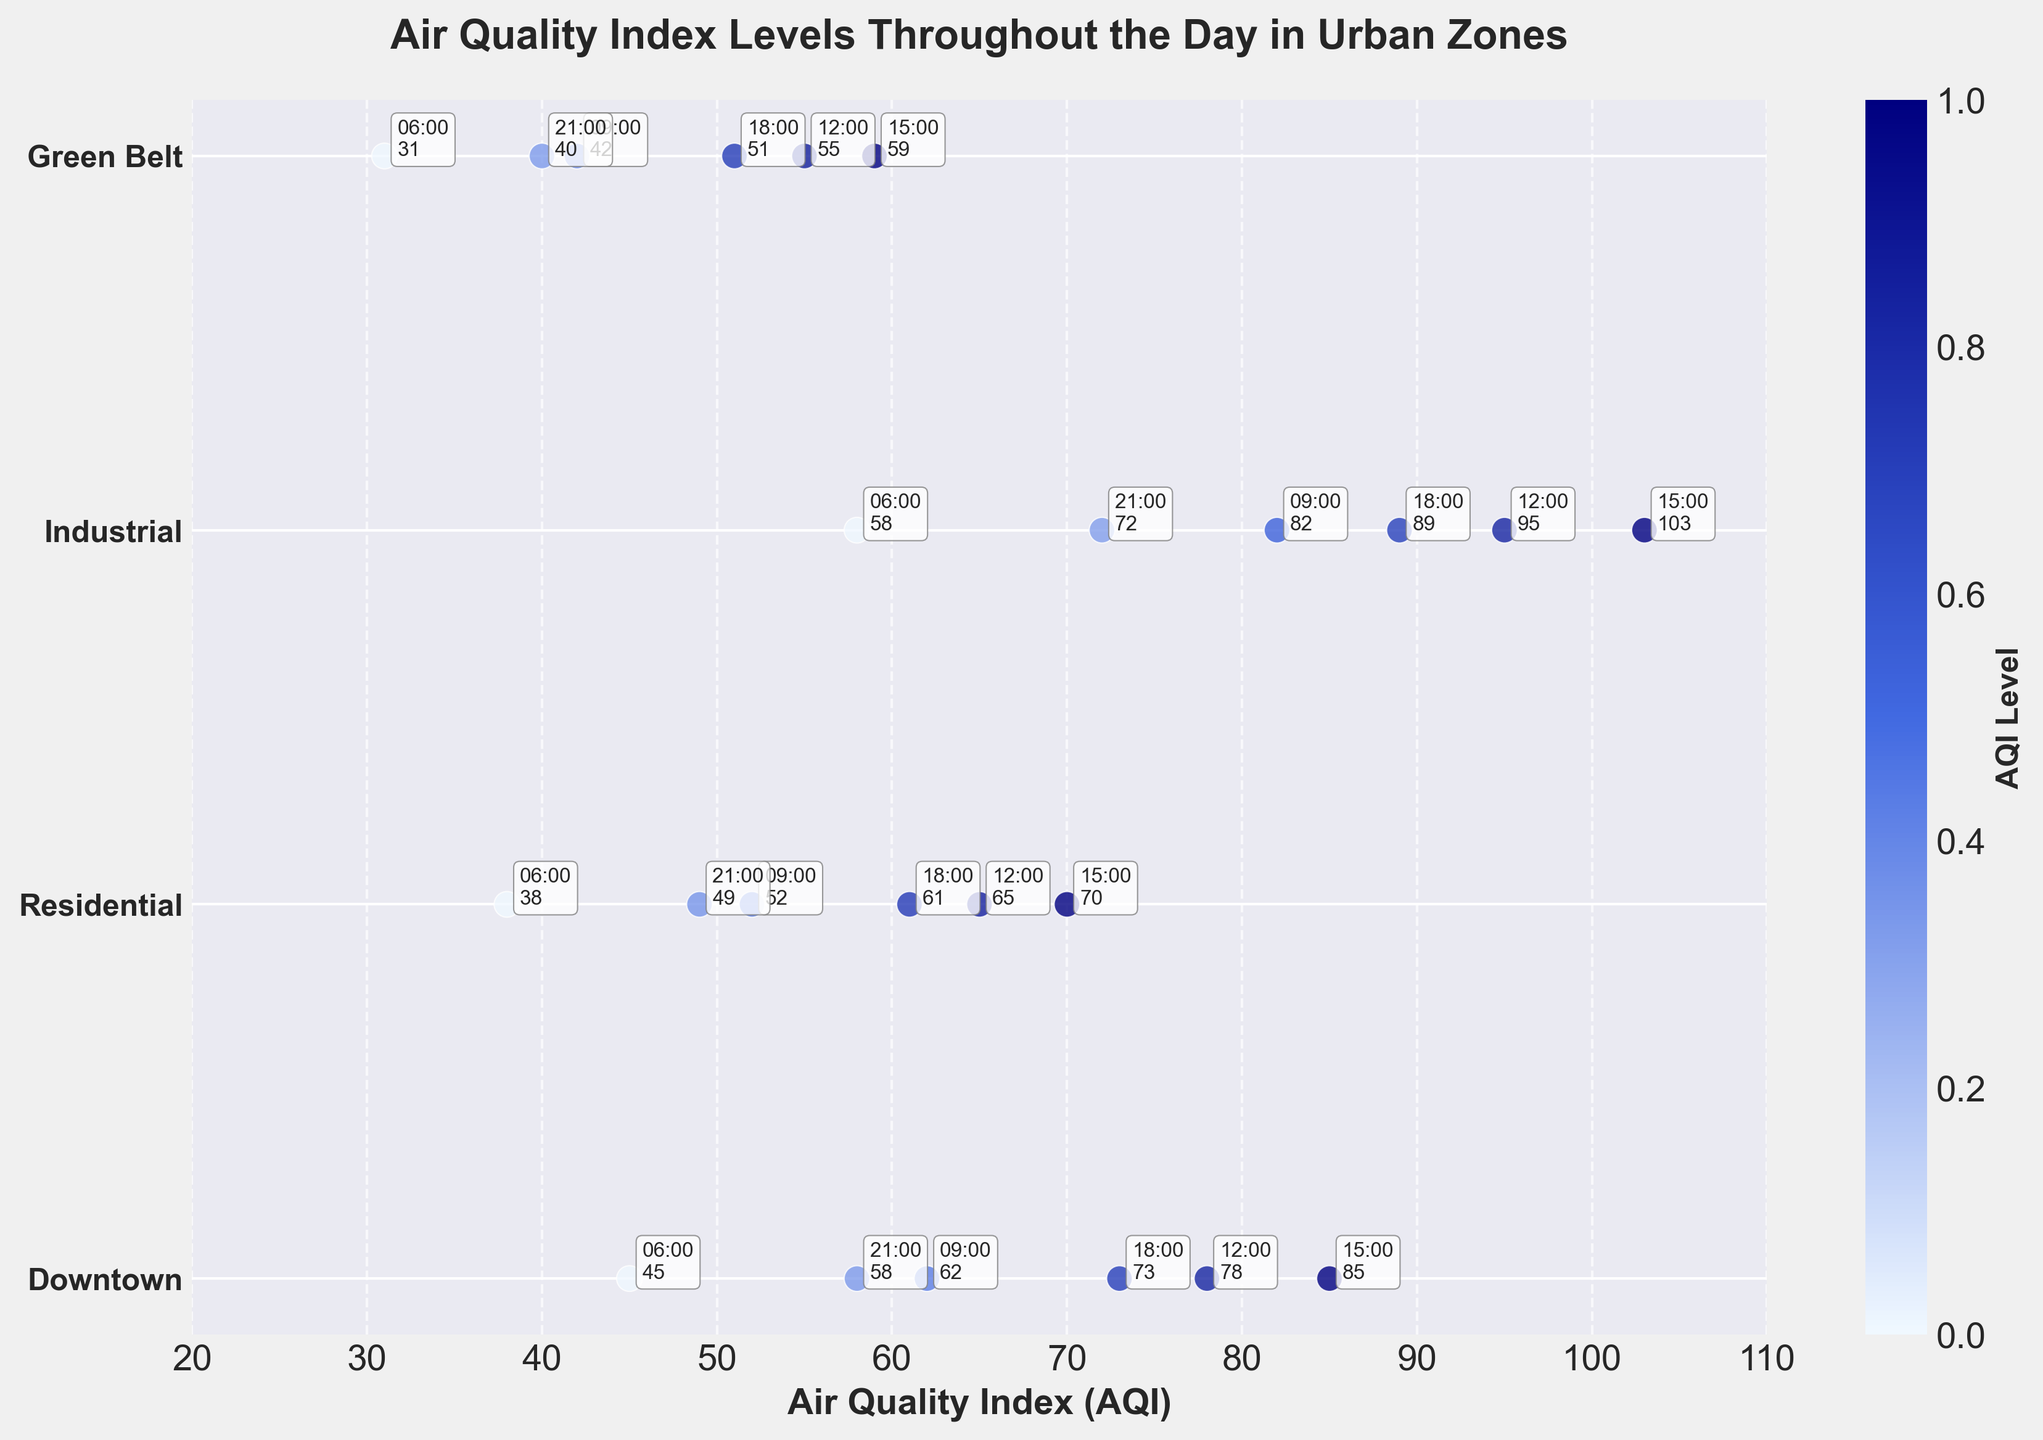What is the title of the figure? The title of the figure is written at the top and usually describes what the plot is about. Here the title says "Air Quality Index Levels Throughout the Day in Urban Zones."
Answer: Air Quality Index Levels Throughout the Day in Urban Zones What are the unique zones displayed in the figure? The unique zones are labeled on the y-axis of the figure. They are "Downtown," "Residential," "Industrial," and "Green Belt."
Answer: Downtown, Residential, Industrial, Green Belt Which zone has the highest AQI level and what is that level? By observing the scatter plots, the highest point belongs to the "Industrial" zone, specifically at 15:00 with an AQI of 103.
Answer: Industrial, 103 At what time does the "Residential" zone have the highest AQI level? The time labels can be seen beside the scatter points for the "Residential" zone, showing that the highest AQI is at 15:00 with a value of 70.
Answer: 15:00 What is the range of AQI values for the "Green Belt" zone? By looking at the scatter points for "Green Belt," the lowest AQI is at 06:00 with a value of 31 and the highest is at 15:00 with a value of 59. Thus, the range is 31 to 59.
Answer: 31 to 59 Comparing "Downtown" and "Residential," which zone has a higher AQI level at 18:00? The AQI levels at 18:00 for "Downtown" and "Residential" are annotated near the points, showing 73 for "Downtown" and 61 for "Residential." So, "Downtown" is higher.
Answer: Downtown On average, which zone has the lowest AQI level? Calculate the average AQI for each zone by summing the AQI values and dividing by the number of time points (6 for each zone). "Green Belt" has the lowest averages: (31+42+55+59+51+40) / 6 = 46.33.
Answer: Green Belt How does the AQI level change from 06:00 to 21:00 in the "Industrial" zone? Track the AQI values in "Industrial" from morning to evening: 58 at 06:00, 82 at 09:00, 95 at 12:00, 103 at 15:00, 89 at 18:00, and 72 at 21:00. The AQI increases initially until it peaks at 103 by 15:00, then it decreases in the evening.
Answer: Increases then decreases Which zone has the least variability in AQI levels throughout the day? Variability can be analyzed by assessing the spread of AQI values. "Green Belt" has the least variability with AQI values ranging from 31 to 59, compared to other zones.
Answer: Green Belt 